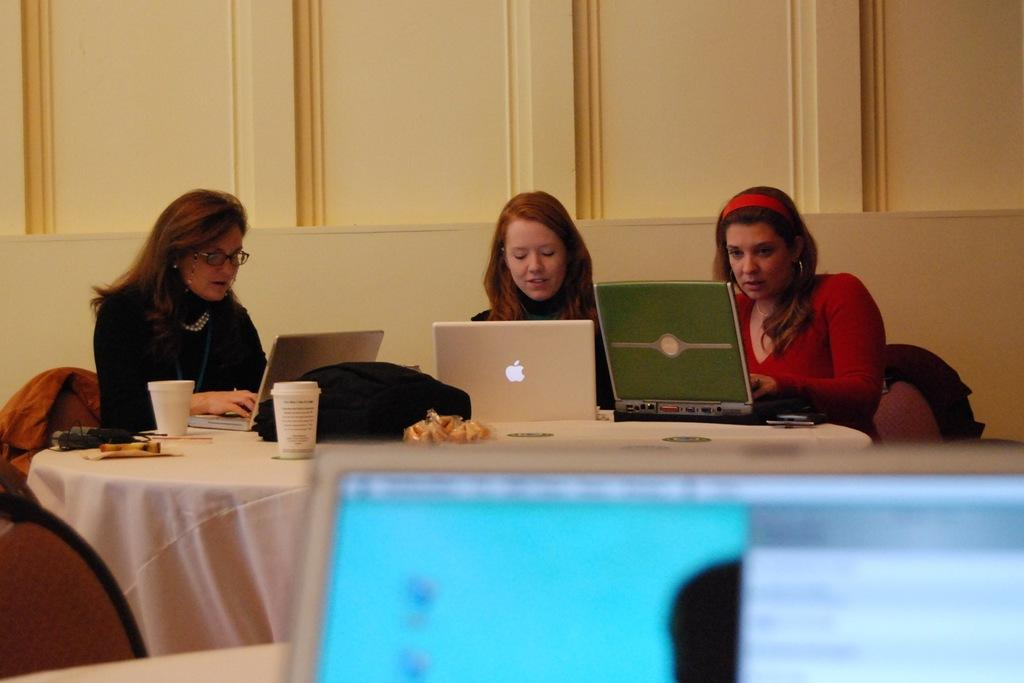How many women are present in the image? There are three women in the image. What are the women doing in the image? The women are sitting on chairs and working on their laptops. How are the chairs arranged in the image? The chairs are arranged around a round table. What can be seen in the background of the image? There is a wall visible in the background. What type of pie is being served on the table in the image? There is no pie present in the image; the women are working on their laptops. 